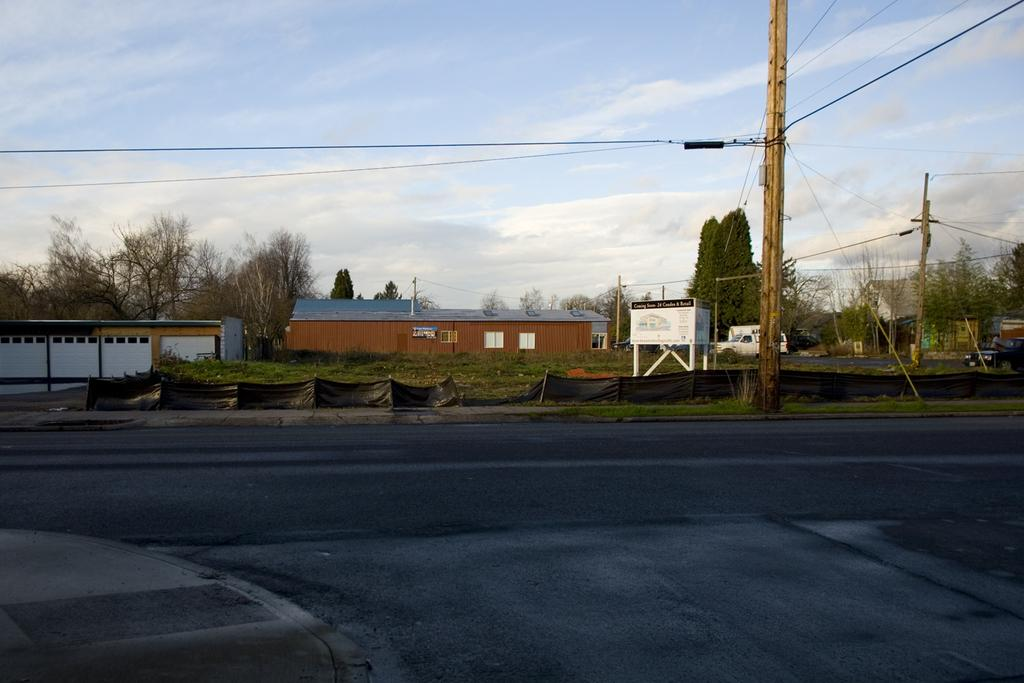What is the main feature of the image? There is a road in the image. What can be seen on the side of the road? Electric poles are present on the side of the road, and wires are visible on the electric poles. What is visible in the background of the image? There are houses, trees, and sign boards in the background of the image. What is the color of the sky in the image? The sky is blue in the image. What type of canvas is being used to paint the houses in the image? There is no canvas or painting activity present in the image; it is a photograph of a real scene. How does the ball bounce on the road in the image? There is no ball present in the image, so it cannot be determined how a ball would bounce on the road. 